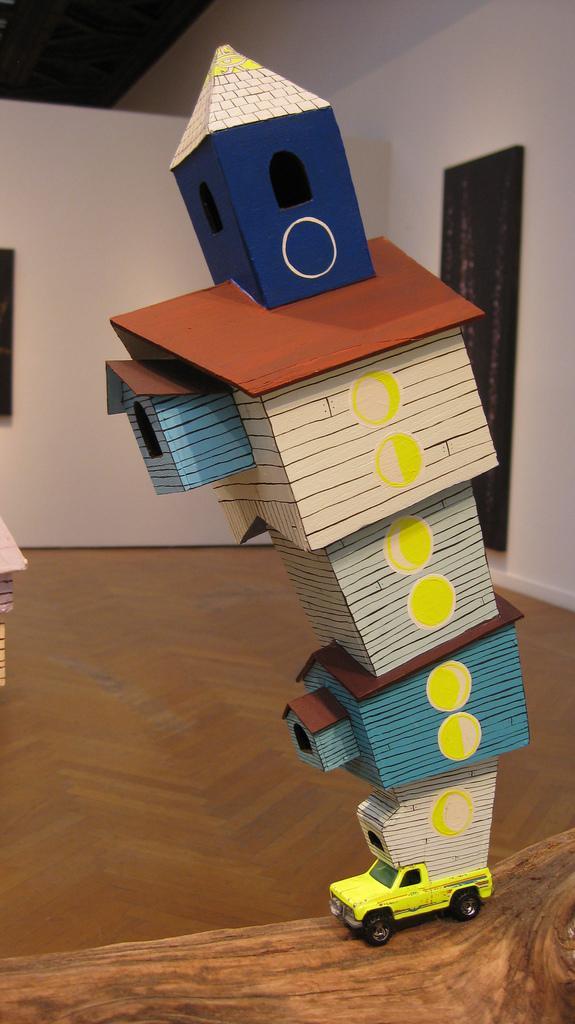Could you give a brief overview of what you see in this image? In this image I see a toy car which is of yellow in color and it is on the floor and it is carrying a miniature houses on top of it. In the background I see a wall, which is cream in color. 